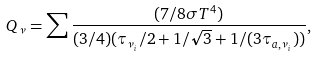Convert formula to latex. <formula><loc_0><loc_0><loc_500><loc_500>Q _ { \nu } = \sum { \frac { ( 7 / 8 \sigma T ^ { 4 } ) } { ( 3 / 4 ) ( \tau _ { \nu _ { i } } / 2 + 1 / \sqrt { 3 } + 1 / ( 3 \tau _ { a , \nu _ { i } } ) ) } } ,</formula> 